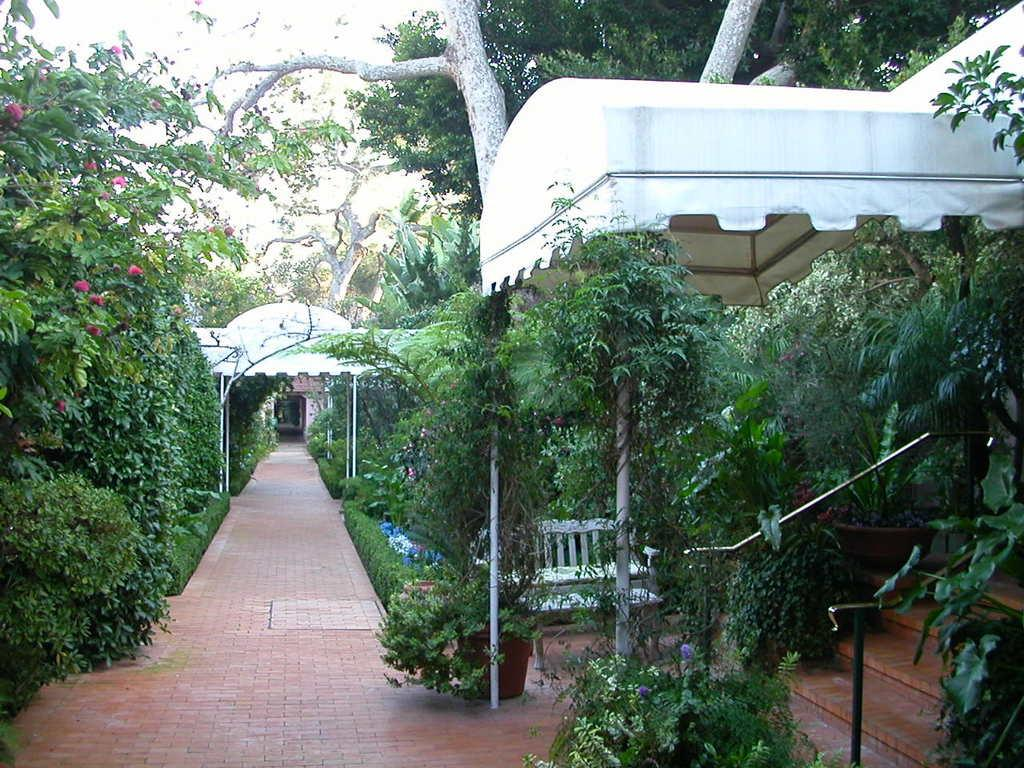What type of area is depicted in the image? There is a garden area in the image. What can be found in the garden? There are many trees in the garden. Is there any seating in the garden? Yes, there is a bench in the garden. Can you see a fireman smiling near the string in the image? There is no fireman, string, or smile present in the image. 